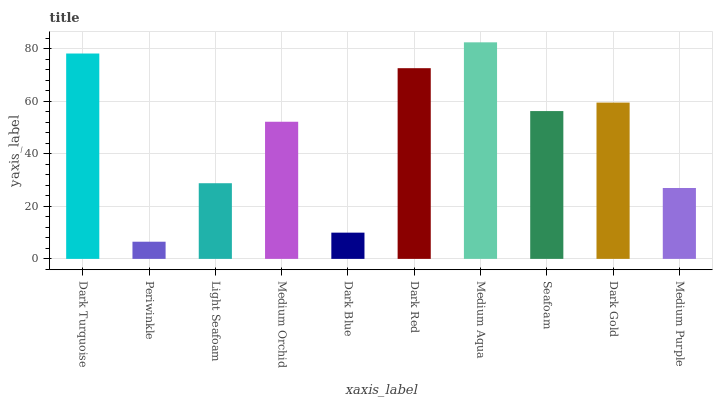Is Periwinkle the minimum?
Answer yes or no. Yes. Is Medium Aqua the maximum?
Answer yes or no. Yes. Is Light Seafoam the minimum?
Answer yes or no. No. Is Light Seafoam the maximum?
Answer yes or no. No. Is Light Seafoam greater than Periwinkle?
Answer yes or no. Yes. Is Periwinkle less than Light Seafoam?
Answer yes or no. Yes. Is Periwinkle greater than Light Seafoam?
Answer yes or no. No. Is Light Seafoam less than Periwinkle?
Answer yes or no. No. Is Seafoam the high median?
Answer yes or no. Yes. Is Medium Orchid the low median?
Answer yes or no. Yes. Is Light Seafoam the high median?
Answer yes or no. No. Is Periwinkle the low median?
Answer yes or no. No. 